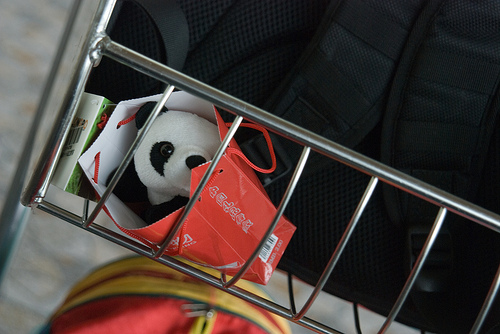<image>
Is the panda in the bag? Yes. The panda is contained within or inside the bag, showing a containment relationship. 